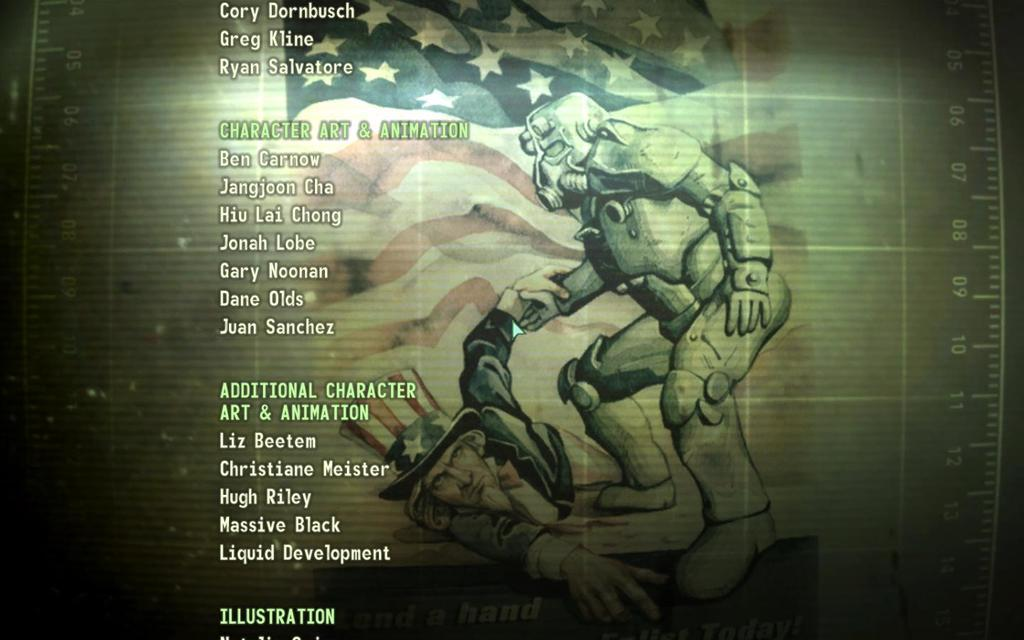<image>
Share a concise interpretation of the image provided. Screen showing a robot picking up a man and the words "Character Art & Animation" next to it. 